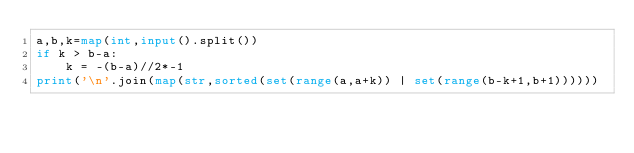<code> <loc_0><loc_0><loc_500><loc_500><_Python_>a,b,k=map(int,input().split())
if k > b-a:
    k = -(b-a)//2*-1
print('\n'.join(map(str,sorted(set(range(a,a+k)) | set(range(b-k+1,b+1))))))</code> 